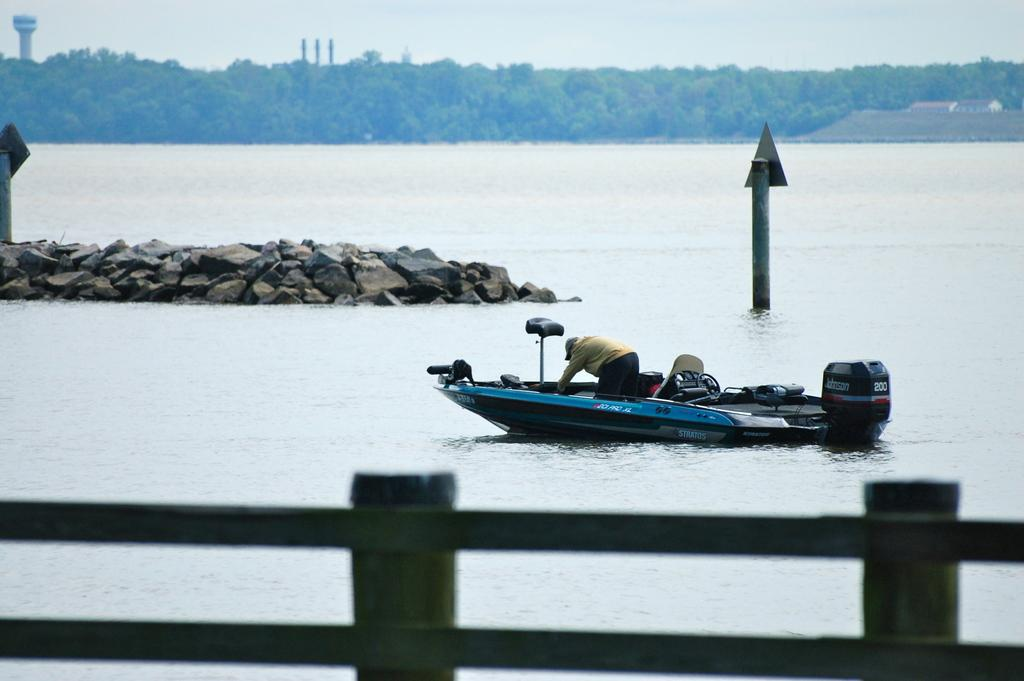What is the main subject of the image? The main subject of the image is a boat on the water. What other objects or structures can be seen in the image? Stones, trees, houses, a fence, poles, boards, a tower, and the sky are visible in the image. Can you describe the setting of the image? The image features a boat on the water, surrounded by trees, houses, and a tower, with a fence and poles nearby. The sky is visible in the background. Where is the library located in the image? There is no library present in the image. What type of farmer is shown working in the image? There is no farmer present in the image. 